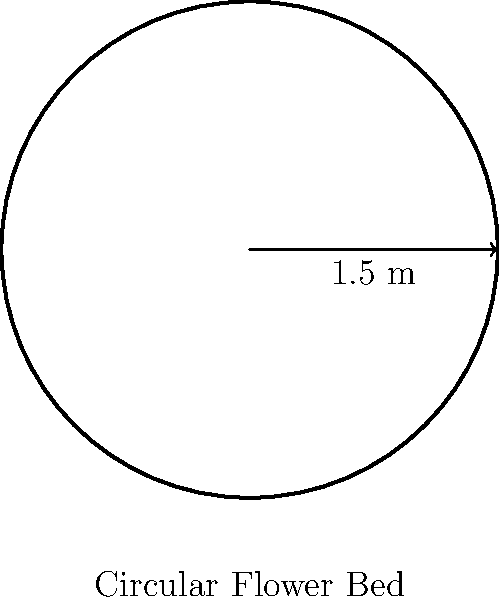You're designing a circular flower bed for a client's garden. The diameter of the bed is 3 meters. Calculate the circumference of the flower bed to determine how much decorative edging you'll need to purchase. To find the circumference of a circular flower bed, we'll use the formula:

$$C = \pi d$$

Where:
$C$ = circumference
$\pi$ = pi (approximately 3.14159)
$d$ = diameter

Given:
Diameter ($d$) = 3 meters

Step 1: Substitute the values into the formula
$$C = \pi \times 3$$

Step 2: Calculate
$$C = 3.14159 \times 3 = 9.42477 \text{ meters}$$

Step 3: Round to two decimal places for practical use
$$C \approx 9.42 \text{ meters}$$

Therefore, you'll need approximately 9.42 meters of decorative edging for the circular flower bed.
Answer: 9.42 meters 